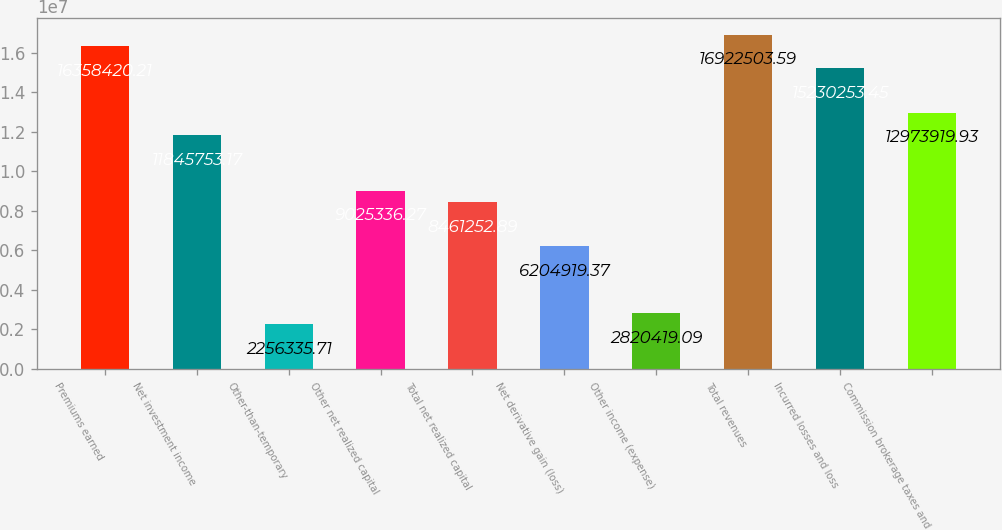Convert chart to OTSL. <chart><loc_0><loc_0><loc_500><loc_500><bar_chart><fcel>Premiums earned<fcel>Net investment income<fcel>Other-than-temporary<fcel>Other net realized capital<fcel>Total net realized capital<fcel>Net derivative gain (loss)<fcel>Other income (expense)<fcel>Total revenues<fcel>Incurred losses and loss<fcel>Commission brokerage taxes and<nl><fcel>1.63584e+07<fcel>1.18458e+07<fcel>2.25634e+06<fcel>9.02534e+06<fcel>8.46125e+06<fcel>6.20492e+06<fcel>2.82042e+06<fcel>1.69225e+07<fcel>1.52303e+07<fcel>1.29739e+07<nl></chart> 